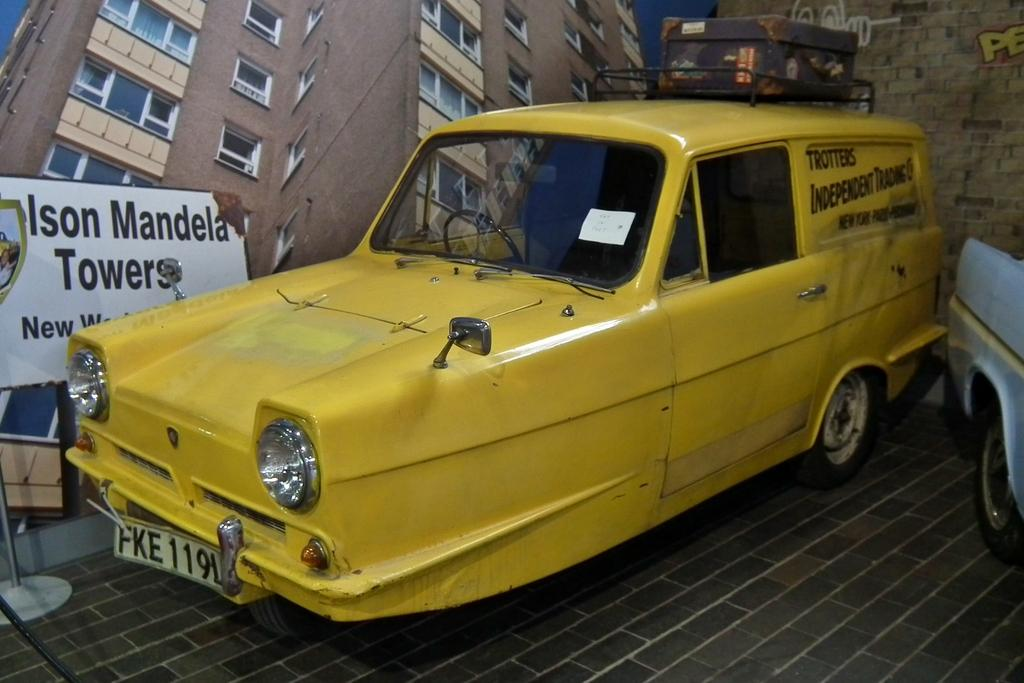What objects are on the floor in the image? There are two cars on the floor in the image. What can be seen on the wall in the image? There is a poster of a building and a board with text in the image. What type of text is present in the image? There is a board with text and a wall with text in the background of the image. How many cats are sitting on the cars in the image? There are no cats present in the image; it only features two cars on the floor. 